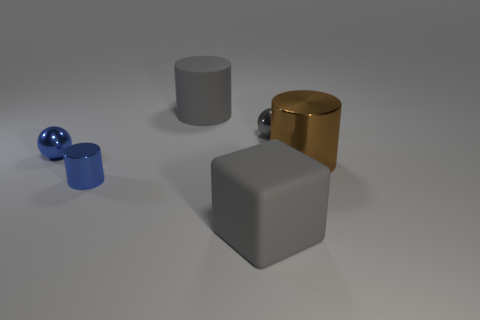Add 2 big metal things. How many objects exist? 8 Subtract all balls. How many objects are left? 4 Add 5 small purple balls. How many small purple balls exist? 5 Subtract 1 gray cubes. How many objects are left? 5 Subtract all big metal objects. Subtract all big brown cylinders. How many objects are left? 4 Add 2 blue metallic things. How many blue metallic things are left? 4 